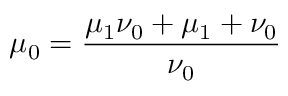<formula> <loc_0><loc_0><loc_500><loc_500>\mu _ { 0 } = \frac { \mu _ { 1 } \nu _ { 0 } + \mu _ { 1 } + \nu _ { 0 } } { \nu _ { 0 } }</formula> 